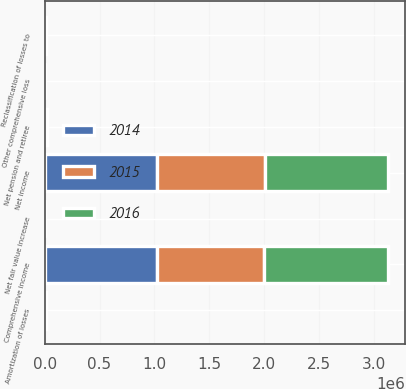<chart> <loc_0><loc_0><loc_500><loc_500><stacked_bar_chart><ecel><fcel>Net income<fcel>Net pension and retiree<fcel>Amortization of losses<fcel>Net fair value increase<fcel>Reclassification of losses to<fcel>Other comprehensive loss<fcel>Comprehensive income<nl><fcel>2016<fcel>1.12338e+06<fcel>7783<fcel>3471<fcel>3<fcel>3708<fcel>601<fcel>1.12278e+06<nl><fcel>2015<fcel>984485<fcel>7906<fcel>3526<fcel>70<fcel>2836<fcel>1614<fcel>982871<nl><fcel>2014<fcel>1.02131e+06<fcel>7517<fcel>3495<fcel>163<fcel>2288<fcel>1864<fcel>1.01944e+06<nl></chart> 